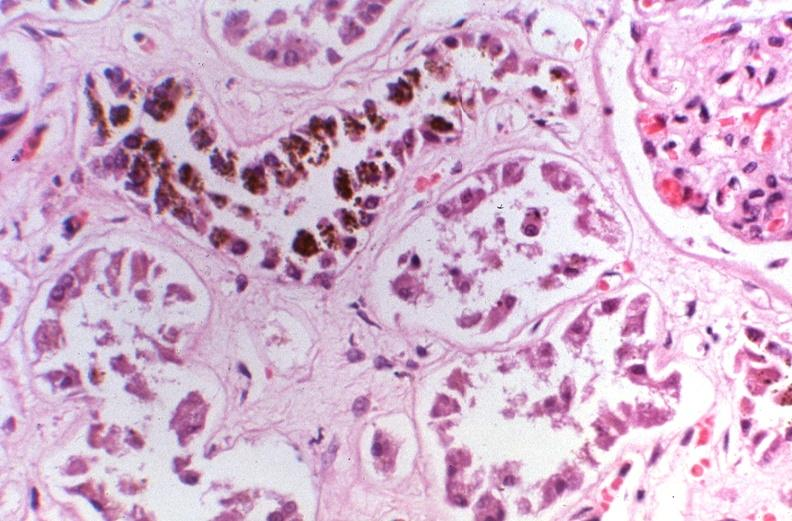what does this image show?
Answer the question using a single word or phrase. Kidney 